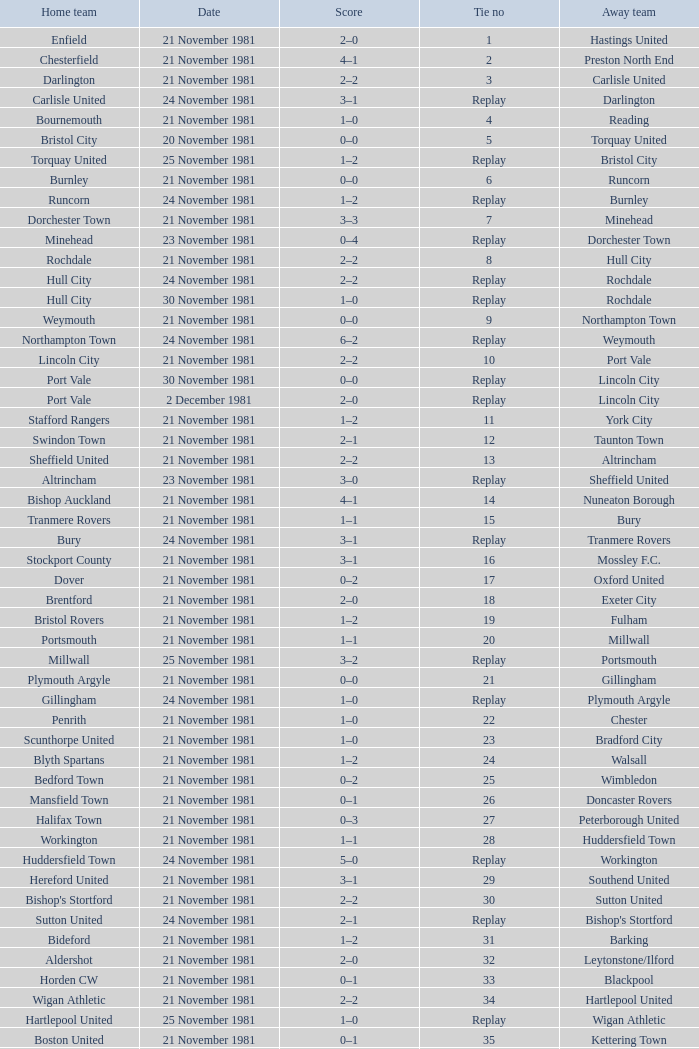Minehead has what tie number? Replay. 